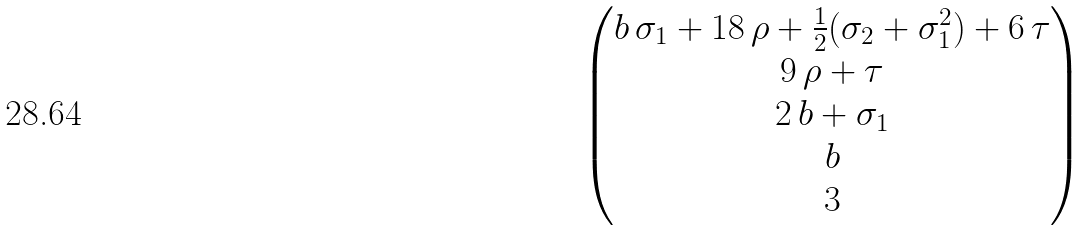<formula> <loc_0><loc_0><loc_500><loc_500>\begin{pmatrix} b \, \sigma _ { 1 } + 1 8 \, \rho + \frac { 1 } { 2 } ( \sigma _ { 2 } + \sigma _ { 1 } ^ { 2 } ) + 6 \, \tau \\ 9 \, \rho + \tau \\ 2 \, b + \sigma _ { 1 } \\ b \\ 3 \end{pmatrix}</formula> 